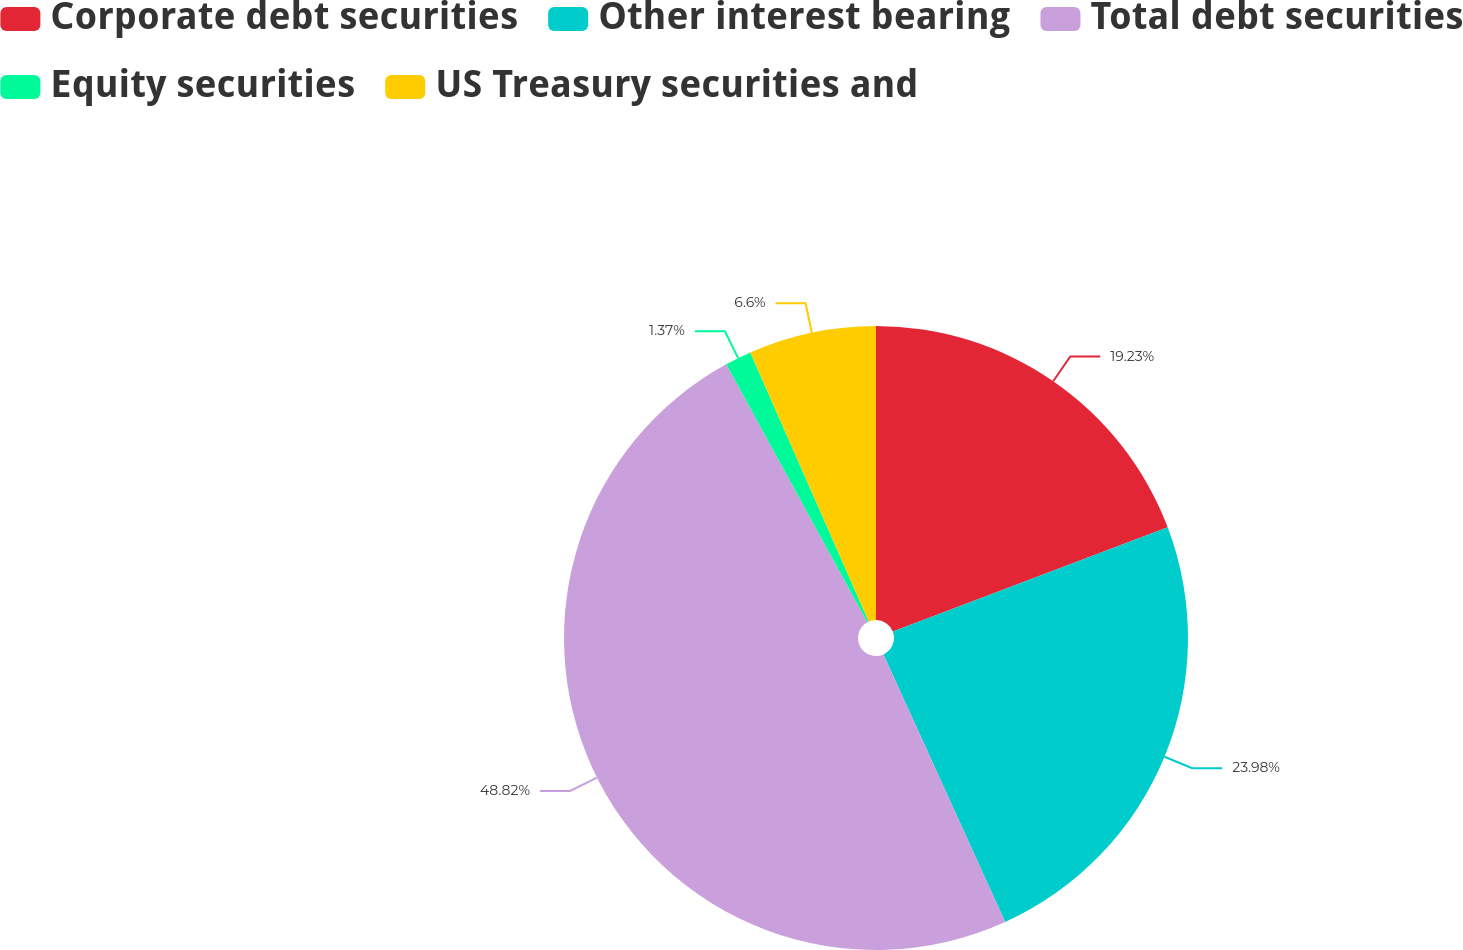Convert chart. <chart><loc_0><loc_0><loc_500><loc_500><pie_chart><fcel>Corporate debt securities<fcel>Other interest bearing<fcel>Total debt securities<fcel>Equity securities<fcel>US Treasury securities and<nl><fcel>19.23%<fcel>23.98%<fcel>48.83%<fcel>1.37%<fcel>6.6%<nl></chart> 